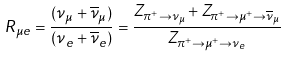Convert formula to latex. <formula><loc_0><loc_0><loc_500><loc_500>R _ { \mu e } = \frac { ( \nu _ { \mu } + \overline { \nu } _ { \mu } ) } { ( \nu _ { e } + \overline { \nu } _ { e } ) } = \frac { Z _ { \pi ^ { + } \to \nu _ { \mu } } + Z _ { \pi ^ { + } \to \mu ^ { + } \to \overline { \nu } _ { \mu } } } { Z _ { \pi ^ { + } \to \mu ^ { + } \to \nu _ { e } } }</formula> 